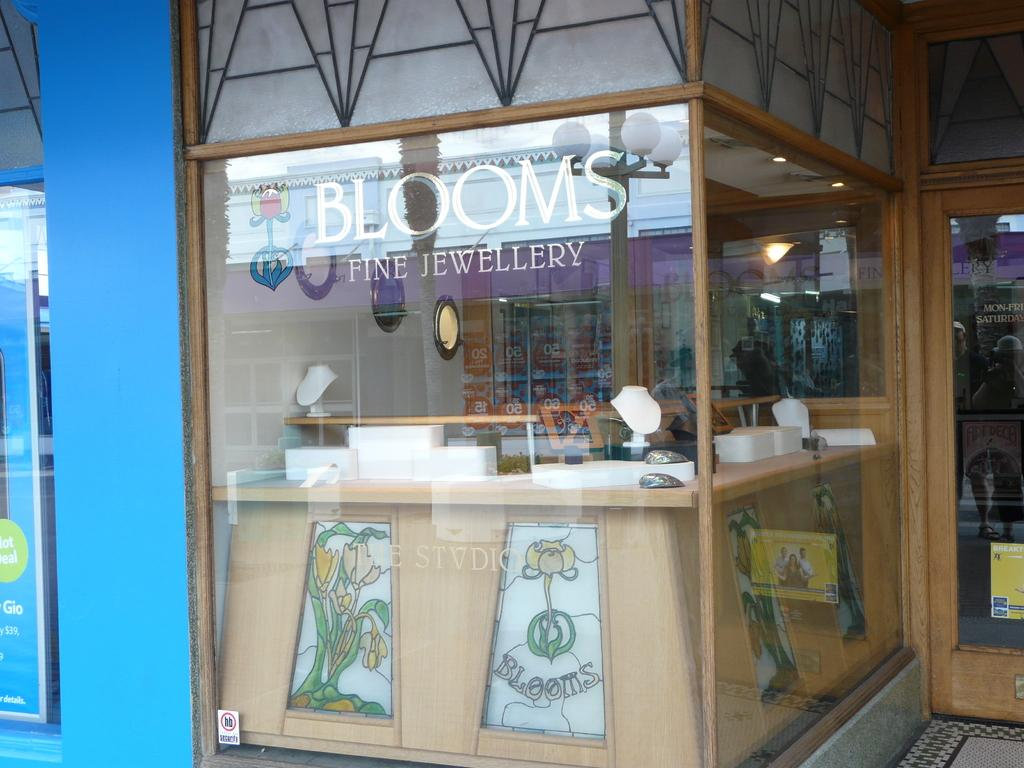<image>
Offer a succinct explanation of the picture presented. A window looking into Blooms Fine Jewelry store. 